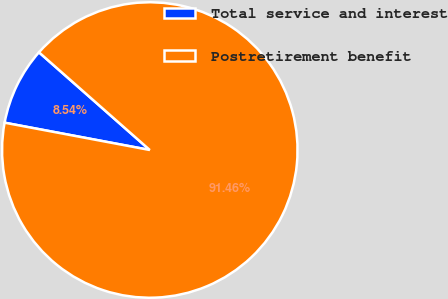Convert chart. <chart><loc_0><loc_0><loc_500><loc_500><pie_chart><fcel>Total service and interest<fcel>Postretirement benefit<nl><fcel>8.54%<fcel>91.46%<nl></chart> 